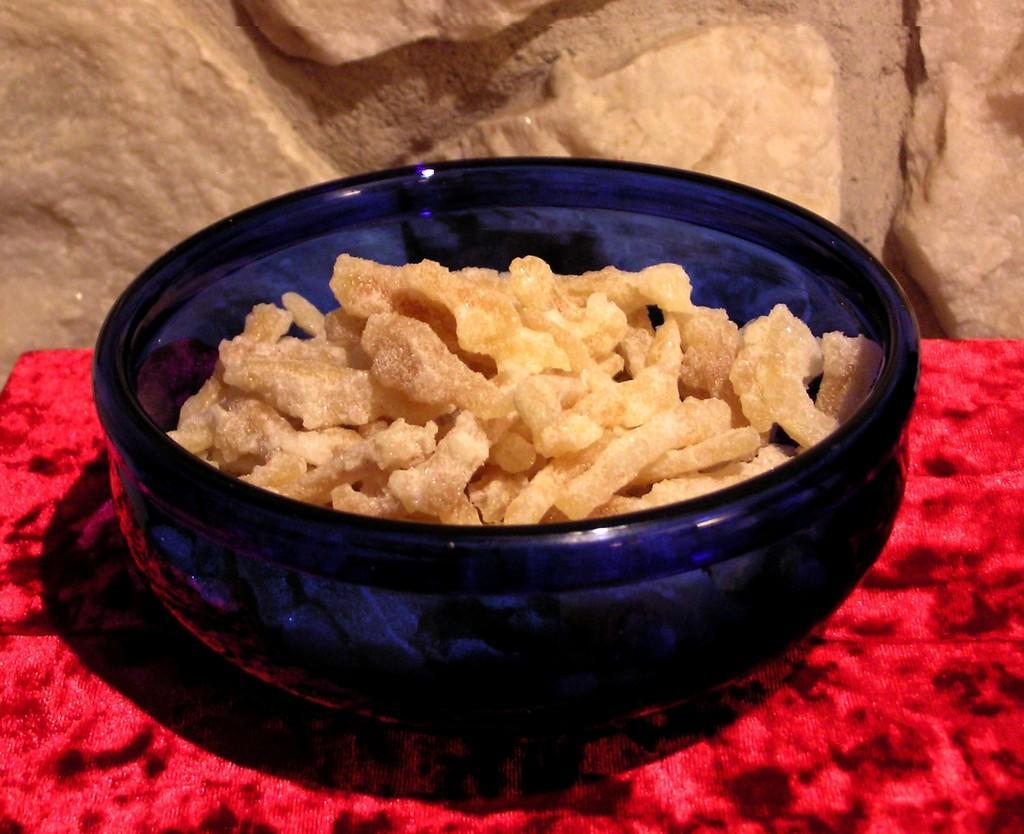Please provide a concise description of this image. In this image there is a bowl on the table with some food item beside that there is a stone wall. 